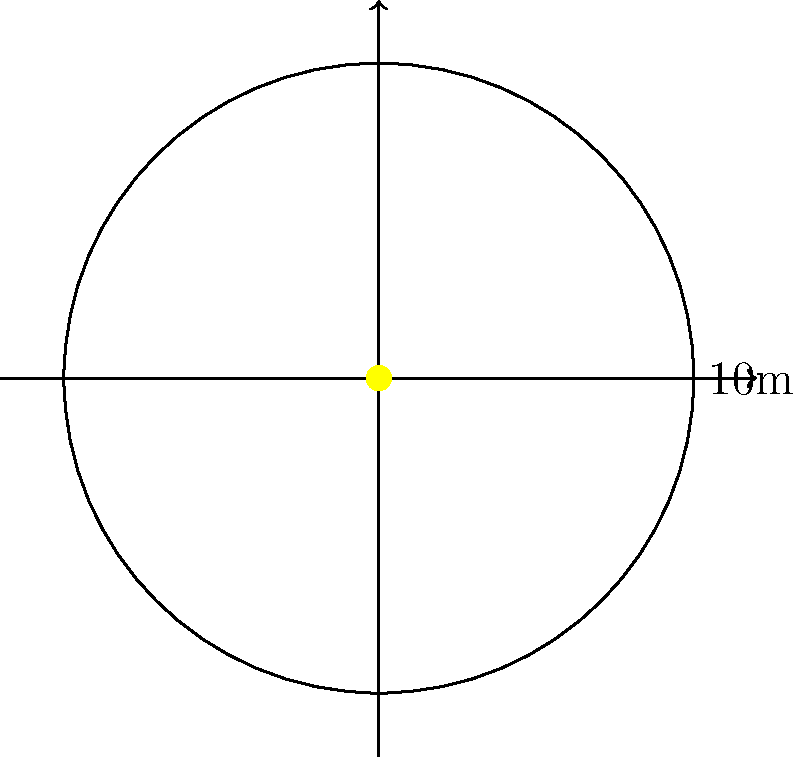The iconic circular logo of Club Deportivo Las Palmas is being painted on the center of the pitch at Estadio de Gran Canaria. If the diameter of the logo is 10 meters, what is the area of the painted logo in square meters? Round your answer to two decimal places. To find the area of the circular logo, we need to follow these steps:

1) We are given the diameter of the circle, which is 10 meters. We need to find the radius.
   Radius = Diameter ÷ 2
   $r = 10 ÷ 2 = 5$ meters

2) The formula for the area of a circle is $A = \pi r^2$, where $r$ is the radius.

3) Substituting our radius value:
   $A = \pi (5)^2$
   $A = \pi (25)$
   $A = 25\pi$ square meters

4) Using $\pi \approx 3.14159$:
   $A \approx 25 * 3.14159 = 78.53975$ square meters

5) Rounding to two decimal places:
   $A \approx 78.54$ square meters

Therefore, the area of the Club Deportivo Las Palmas logo on the pitch is approximately 78.54 square meters.
Answer: $78.54$ m² 